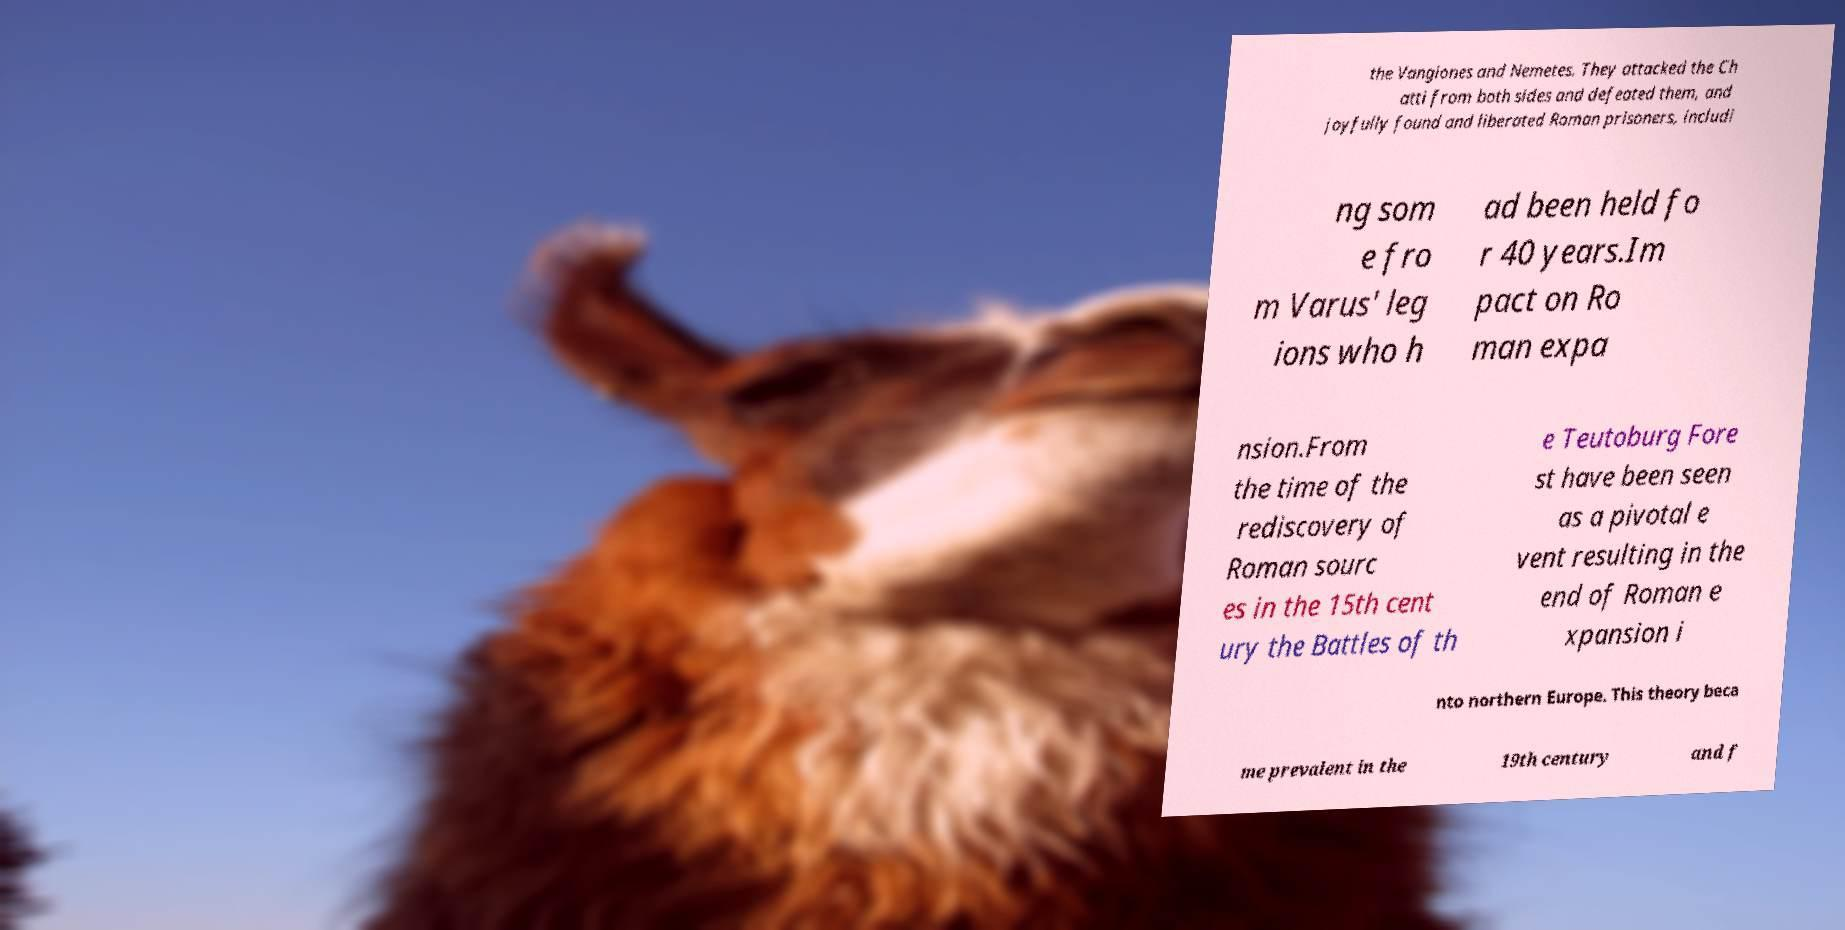There's text embedded in this image that I need extracted. Can you transcribe it verbatim? the Vangiones and Nemetes. They attacked the Ch atti from both sides and defeated them, and joyfully found and liberated Roman prisoners, includi ng som e fro m Varus' leg ions who h ad been held fo r 40 years.Im pact on Ro man expa nsion.From the time of the rediscovery of Roman sourc es in the 15th cent ury the Battles of th e Teutoburg Fore st have been seen as a pivotal e vent resulting in the end of Roman e xpansion i nto northern Europe. This theory beca me prevalent in the 19th century and f 